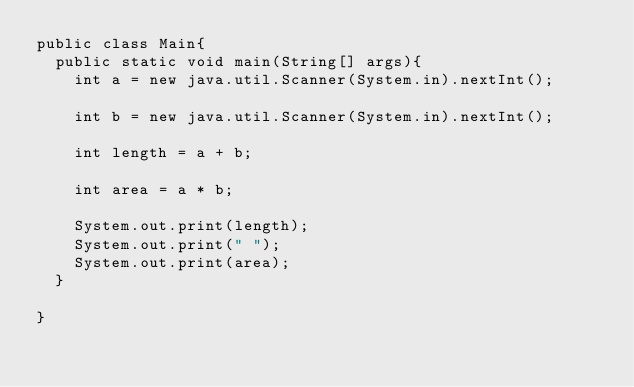<code> <loc_0><loc_0><loc_500><loc_500><_Java_>public class Main{
  public static void main(String[] args){
    int a = new java.util.Scanner(System.in).nextInt();

    int b = new java.util.Scanner(System.in).nextInt();

    int length = a + b;

    int area = a * b;

    System.out.print(length);
    System.out.print(" ");
    System.out.print(area);
  }

}</code> 